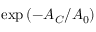Convert formula to latex. <formula><loc_0><loc_0><loc_500><loc_500>e x p \left ( - A _ { C } / A _ { 0 } \right )</formula> 